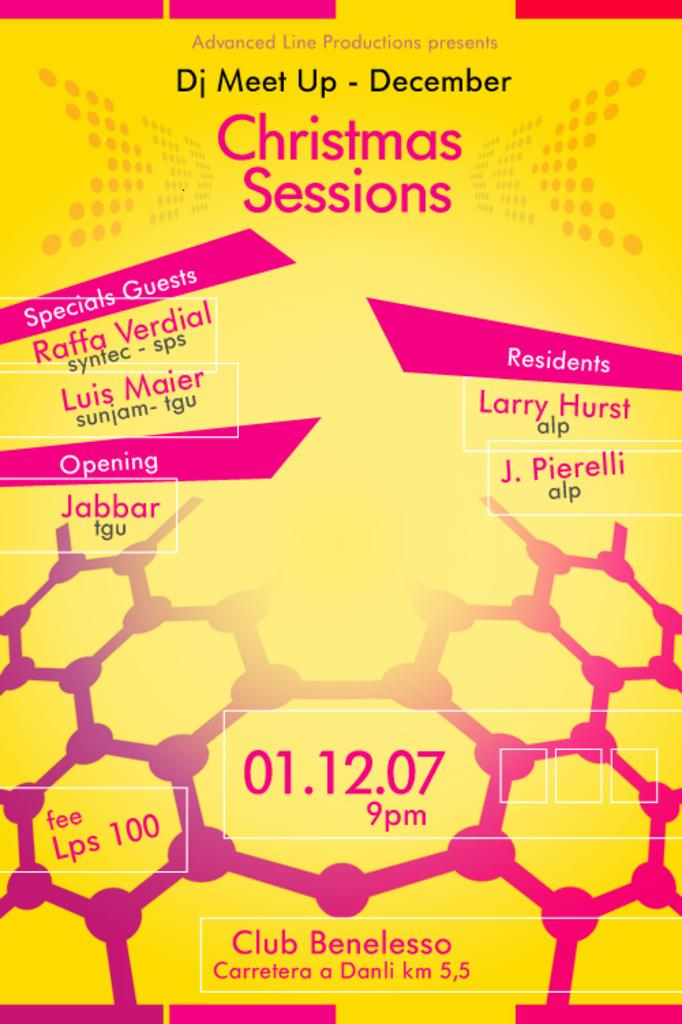Provide a one-sentence caption for the provided image. A poster advertises the Christmas Sessions, including some special guests. 